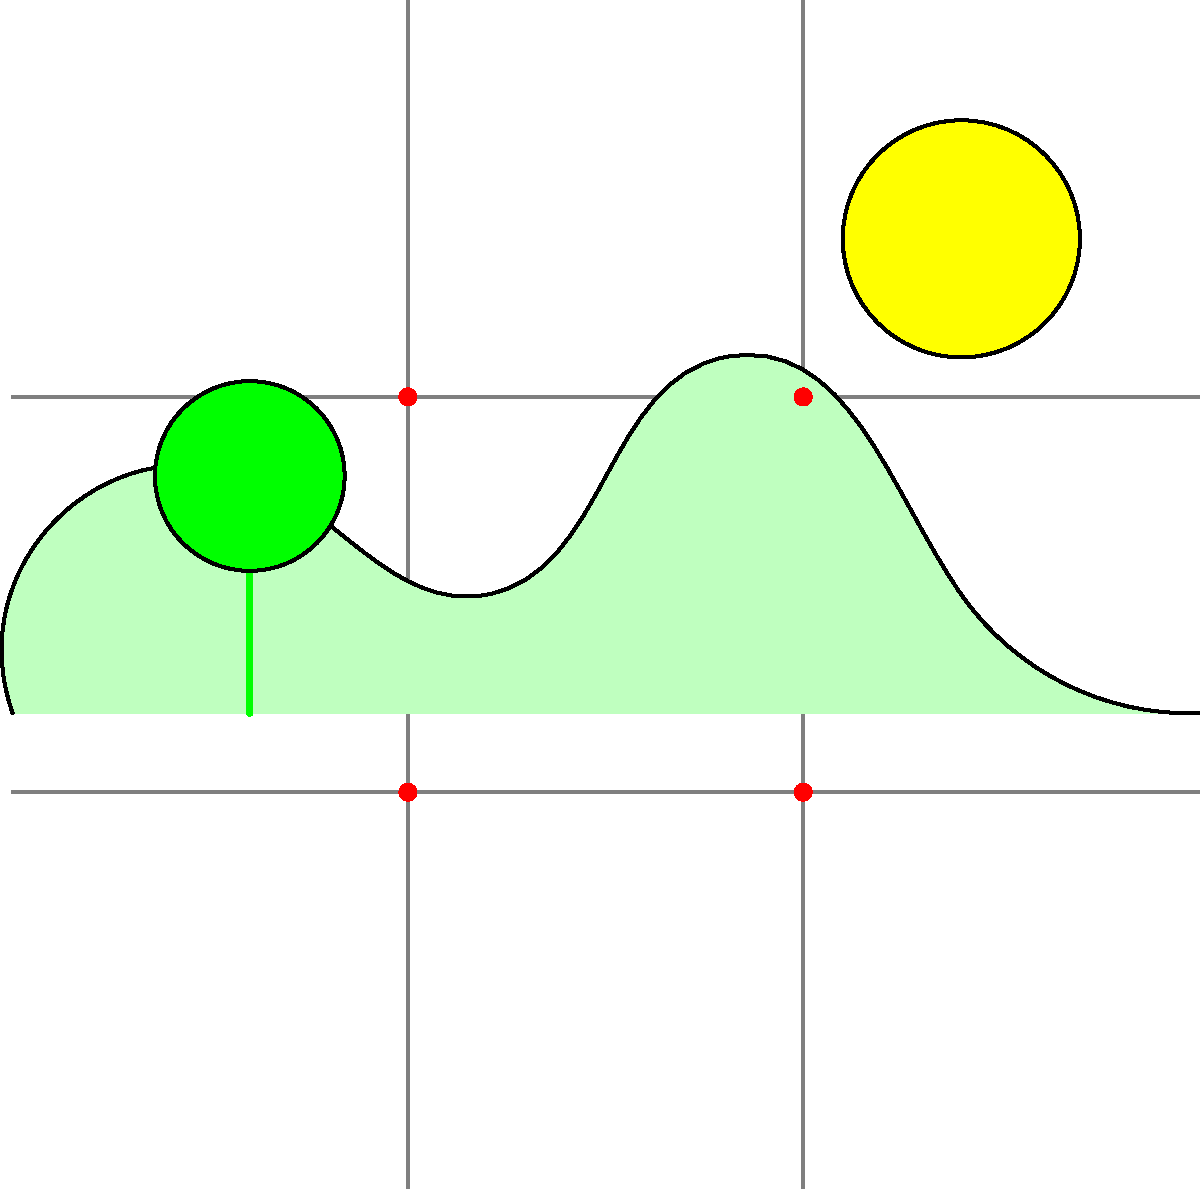Как фотограф-энтузиаст, вы хотите объяснить правило третей своему другу-руководителю стартапа. На изображении выше показана сетка правила третей. Какие элементы композиции вы бы посоветовали разместить в точках пересечения линий сетки для создания более динамичной и интересной фотографии? 1. Правило третей - это основной принцип композиции в фотографии и изобразительном искусстве.

2. Сетка разделяет изображение на девять равных частей двумя горизонтальными и двумя вертикальными линиями.

3. Точки пересечения этих линий (отмечены красным на изображении) считаются сильными точками композиции.

4. Размещение ключевых элементов на этих точках или вдоль линий сетки создает более сбалансированную и интересную композицию.

5. В данном изображении:
   - Солнце можно разместить в верхней правой точке пересечения.
   - Вершину горы можно расположить в верхней левой точке.
   - Дерево можно поместить в нижнюю левую точку.

6. Такое размещение создаст динамичную композицию, привлекающую внимание зрителя к ключевым элементам пейзажа.

7. Объясняя это руководителю стартапа, можно провести аналогию с бизнесом: как правильное расположение элементов на фото привлекает внимание, так и правильное позиционирование продукта на рынке привлекает клиентов.
Answer: Ключевые элементы (солнце, вершина горы, дерево) на точках пересечения линий сетки. 